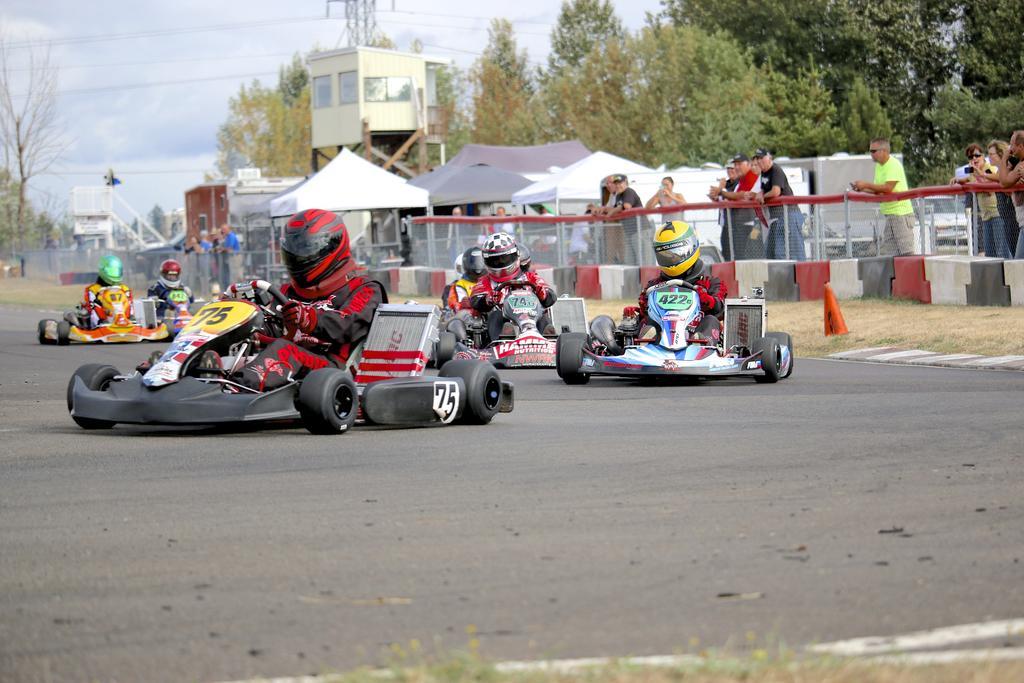In one or two sentences, can you explain what this image depicts? In this picture I can see there is a kart racing and there are few people riding the vehicles. They are wearing helmets and there are few people standing at right, there is a fence and there are few buildings, trees and the sky is clear. 